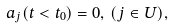<formula> <loc_0><loc_0><loc_500><loc_500>a _ { j } ( t < t _ { 0 } ) = 0 , \, ( j \in U ) ,</formula> 